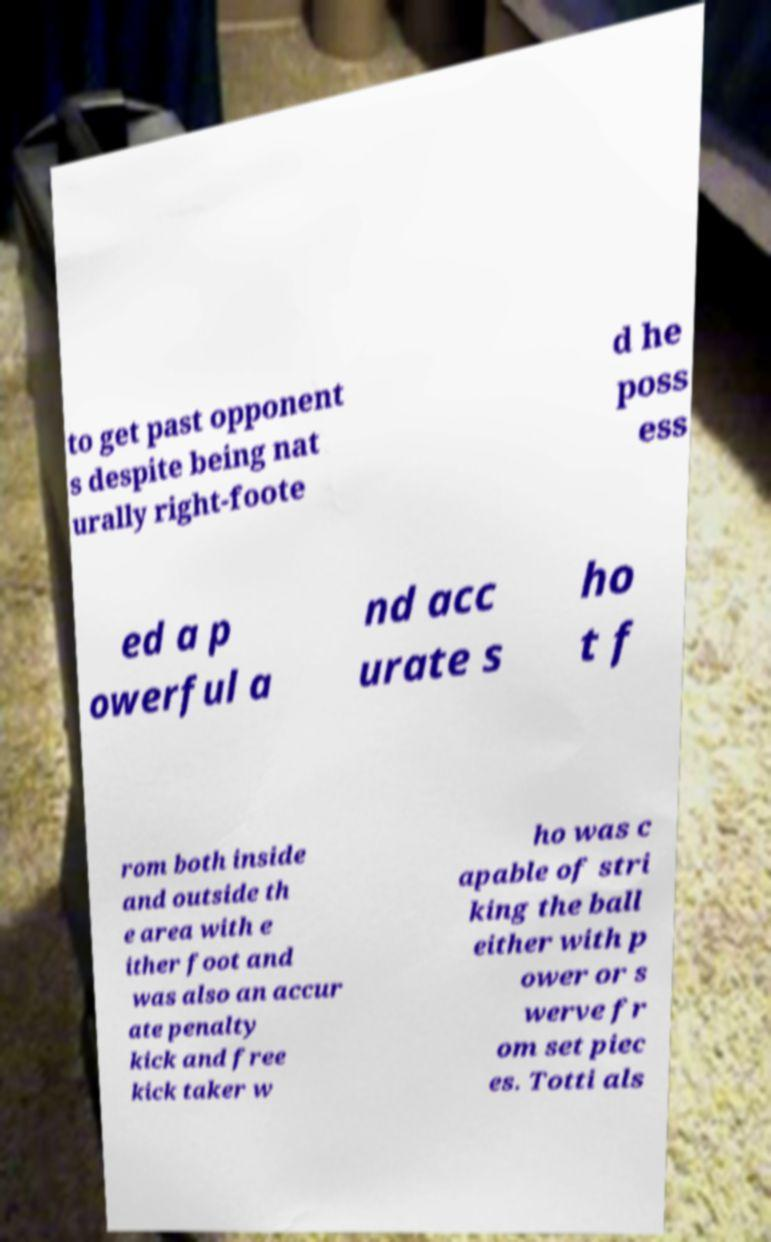Please read and relay the text visible in this image. What does it say? to get past opponent s despite being nat urally right-foote d he poss ess ed a p owerful a nd acc urate s ho t f rom both inside and outside th e area with e ither foot and was also an accur ate penalty kick and free kick taker w ho was c apable of stri king the ball either with p ower or s werve fr om set piec es. Totti als 